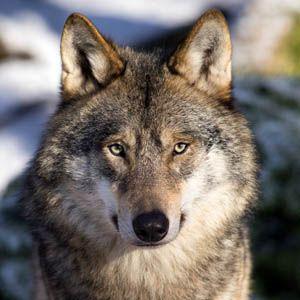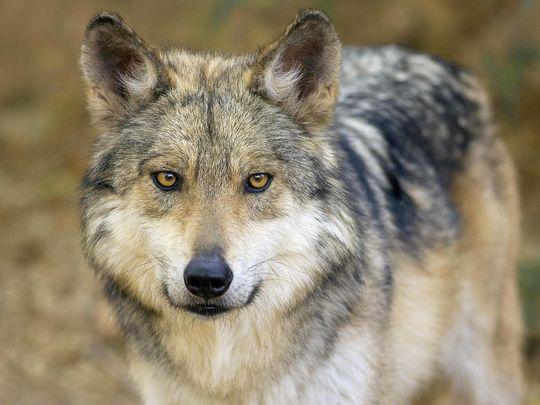The first image is the image on the left, the second image is the image on the right. Analyze the images presented: Is the assertion "An image shows at least one wolf gazing directly leftward." valid? Answer yes or no. No. 